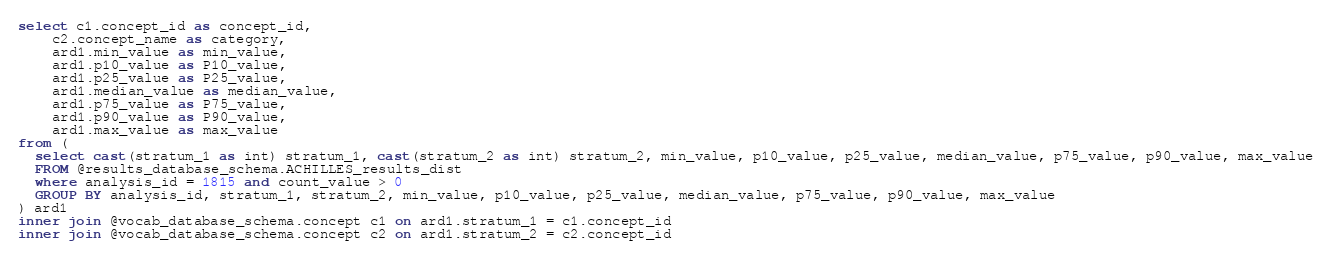Convert code to text. <code><loc_0><loc_0><loc_500><loc_500><_SQL_>select c1.concept_id as concept_id,
	c2.concept_name as category,
	ard1.min_value as min_value,
	ard1.p10_value as P10_value,
	ard1.p25_value as P25_value,
	ard1.median_value as median_value,
	ard1.p75_value as P75_value,
	ard1.p90_value as P90_value,
	ard1.max_value as max_value
from (
  select cast(stratum_1 as int) stratum_1, cast(stratum_2 as int) stratum_2, min_value, p10_value, p25_value, median_value, p75_value, p90_value, max_value
  FROM @results_database_schema.ACHILLES_results_dist  
  where analysis_id = 1815 and count_value > 0
  GROUP BY analysis_id, stratum_1, stratum_2, min_value, p10_value, p25_value, median_value, p75_value, p90_value, max_value 
) ard1
inner join @vocab_database_schema.concept c1 on ard1.stratum_1 = c1.concept_id
inner join @vocab_database_schema.concept c2 on ard1.stratum_2 = c2.concept_id
</code> 